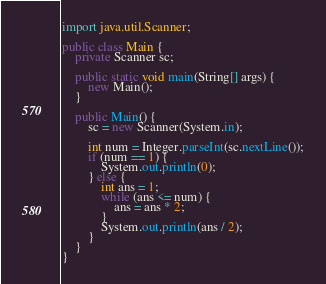Convert code to text. <code><loc_0><loc_0><loc_500><loc_500><_Java_>import java.util.Scanner;

public class Main {
	private Scanner sc;
	
	public static void main(String[] args) {
		new Main();
	}
	
	public Main() {
		sc = new Scanner(System.in);
 
		int num = Integer.parseInt(sc.nextLine());
		if (num == 1) {
			System.out.println(0);
		} else {
			int ans = 1;
			while (ans <= num) {
				ans = ans * 2;
			}
			System.out.println(ans / 2);
		}
	}
}</code> 